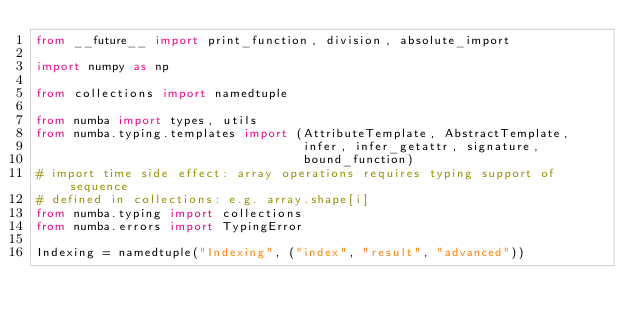Convert code to text. <code><loc_0><loc_0><loc_500><loc_500><_Python_>from __future__ import print_function, division, absolute_import

import numpy as np

from collections import namedtuple

from numba import types, utils
from numba.typing.templates import (AttributeTemplate, AbstractTemplate,
                                    infer, infer_getattr, signature,
                                    bound_function)
# import time side effect: array operations requires typing support of sequence
# defined in collections: e.g. array.shape[i]
from numba.typing import collections
from numba.errors import TypingError

Indexing = namedtuple("Indexing", ("index", "result", "advanced"))

</code> 